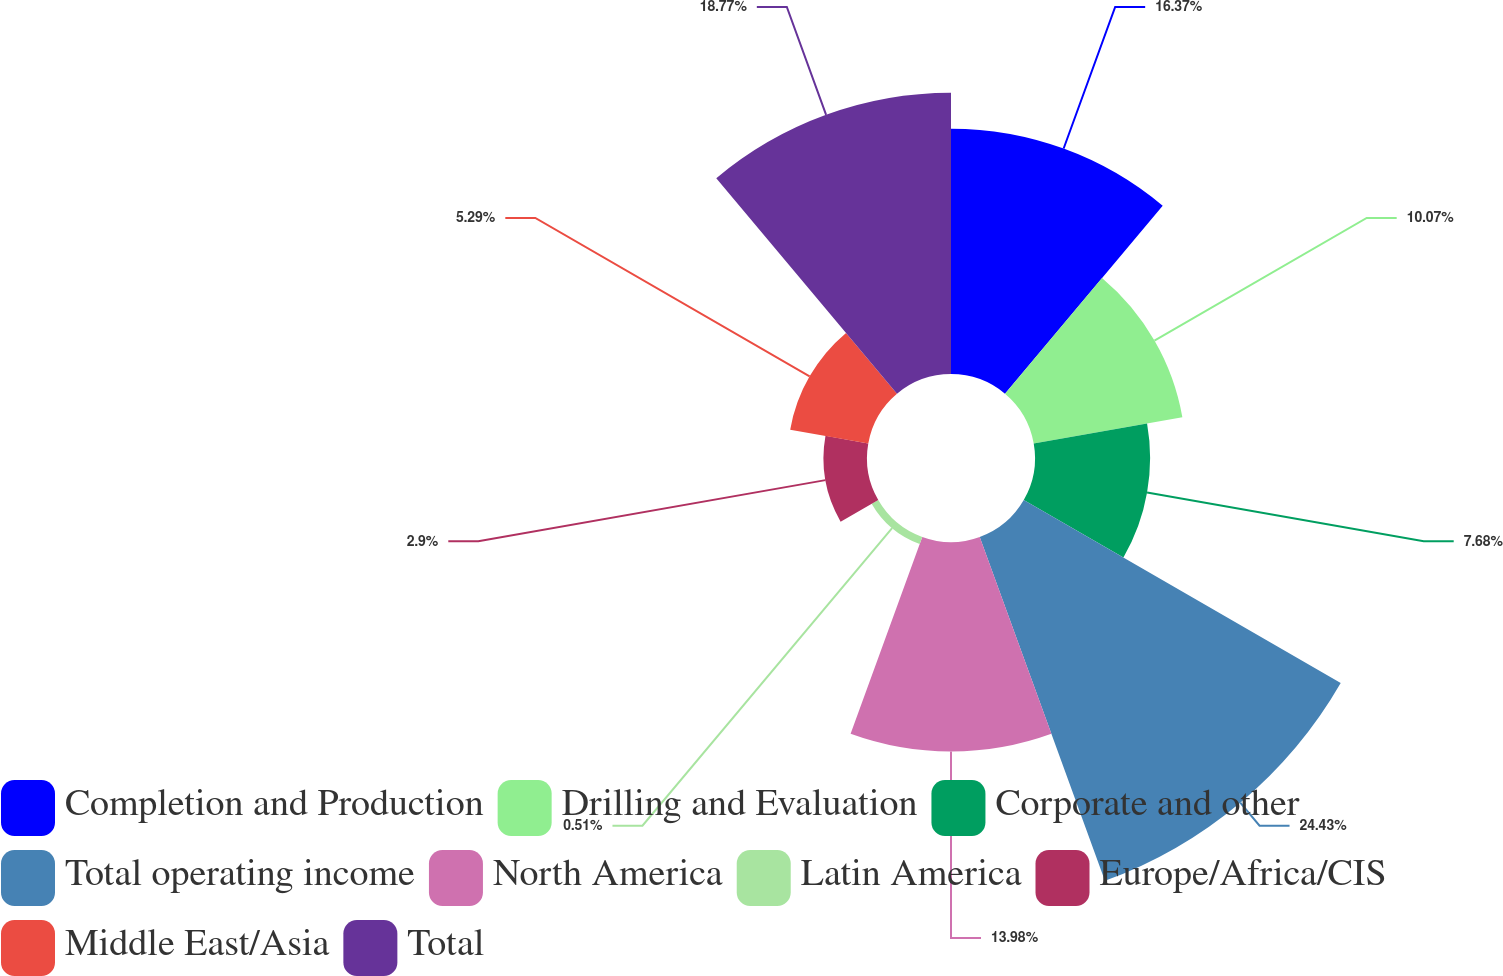Convert chart to OTSL. <chart><loc_0><loc_0><loc_500><loc_500><pie_chart><fcel>Completion and Production<fcel>Drilling and Evaluation<fcel>Corporate and other<fcel>Total operating income<fcel>North America<fcel>Latin America<fcel>Europe/Africa/CIS<fcel>Middle East/Asia<fcel>Total<nl><fcel>16.37%<fcel>10.07%<fcel>7.68%<fcel>24.42%<fcel>13.98%<fcel>0.51%<fcel>2.9%<fcel>5.29%<fcel>18.76%<nl></chart> 